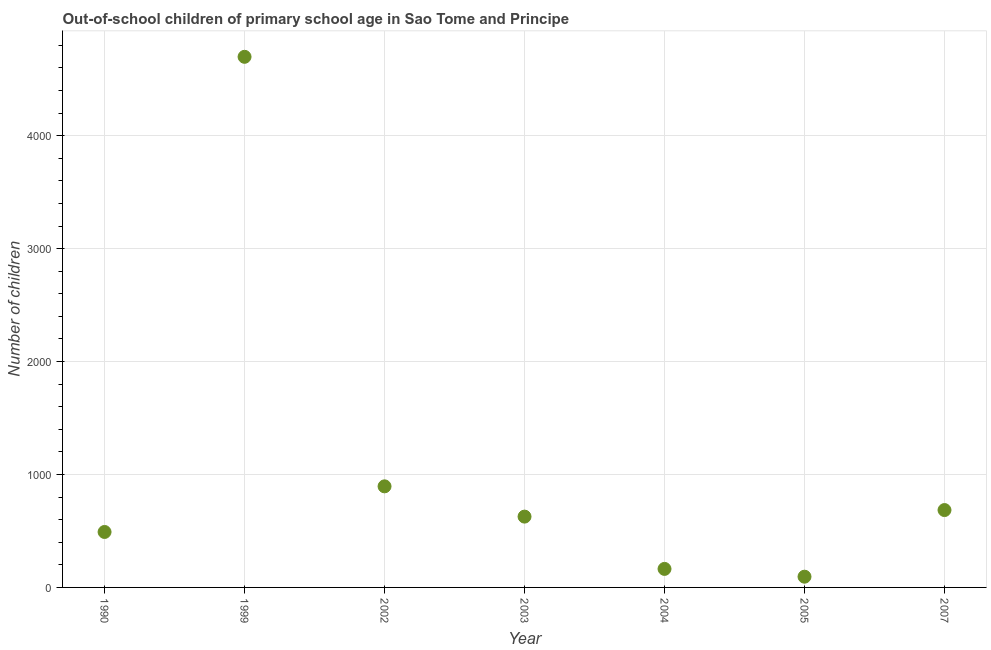What is the number of out-of-school children in 2007?
Your answer should be very brief. 685. Across all years, what is the maximum number of out-of-school children?
Offer a terse response. 4698. Across all years, what is the minimum number of out-of-school children?
Your answer should be compact. 95. What is the sum of the number of out-of-school children?
Offer a very short reply. 7655. What is the difference between the number of out-of-school children in 2005 and 2007?
Your answer should be compact. -590. What is the average number of out-of-school children per year?
Give a very brief answer. 1093.57. What is the median number of out-of-school children?
Your answer should be compact. 627. What is the ratio of the number of out-of-school children in 2004 to that in 2005?
Give a very brief answer. 1.73. What is the difference between the highest and the second highest number of out-of-school children?
Make the answer very short. 3803. Is the sum of the number of out-of-school children in 1999 and 2005 greater than the maximum number of out-of-school children across all years?
Offer a terse response. Yes. What is the difference between the highest and the lowest number of out-of-school children?
Keep it short and to the point. 4603. Does the number of out-of-school children monotonically increase over the years?
Your response must be concise. No. How many dotlines are there?
Give a very brief answer. 1. Are the values on the major ticks of Y-axis written in scientific E-notation?
Provide a succinct answer. No. Does the graph contain any zero values?
Your answer should be very brief. No. What is the title of the graph?
Offer a very short reply. Out-of-school children of primary school age in Sao Tome and Principe. What is the label or title of the Y-axis?
Make the answer very short. Number of children. What is the Number of children in 1990?
Offer a very short reply. 491. What is the Number of children in 1999?
Offer a terse response. 4698. What is the Number of children in 2002?
Provide a short and direct response. 895. What is the Number of children in 2003?
Offer a terse response. 627. What is the Number of children in 2004?
Ensure brevity in your answer.  164. What is the Number of children in 2007?
Your answer should be compact. 685. What is the difference between the Number of children in 1990 and 1999?
Give a very brief answer. -4207. What is the difference between the Number of children in 1990 and 2002?
Provide a short and direct response. -404. What is the difference between the Number of children in 1990 and 2003?
Offer a very short reply. -136. What is the difference between the Number of children in 1990 and 2004?
Your answer should be very brief. 327. What is the difference between the Number of children in 1990 and 2005?
Keep it short and to the point. 396. What is the difference between the Number of children in 1990 and 2007?
Keep it short and to the point. -194. What is the difference between the Number of children in 1999 and 2002?
Your answer should be very brief. 3803. What is the difference between the Number of children in 1999 and 2003?
Make the answer very short. 4071. What is the difference between the Number of children in 1999 and 2004?
Keep it short and to the point. 4534. What is the difference between the Number of children in 1999 and 2005?
Make the answer very short. 4603. What is the difference between the Number of children in 1999 and 2007?
Your response must be concise. 4013. What is the difference between the Number of children in 2002 and 2003?
Provide a succinct answer. 268. What is the difference between the Number of children in 2002 and 2004?
Offer a terse response. 731. What is the difference between the Number of children in 2002 and 2005?
Your response must be concise. 800. What is the difference between the Number of children in 2002 and 2007?
Provide a short and direct response. 210. What is the difference between the Number of children in 2003 and 2004?
Offer a very short reply. 463. What is the difference between the Number of children in 2003 and 2005?
Keep it short and to the point. 532. What is the difference between the Number of children in 2003 and 2007?
Your answer should be compact. -58. What is the difference between the Number of children in 2004 and 2007?
Offer a very short reply. -521. What is the difference between the Number of children in 2005 and 2007?
Make the answer very short. -590. What is the ratio of the Number of children in 1990 to that in 1999?
Keep it short and to the point. 0.1. What is the ratio of the Number of children in 1990 to that in 2002?
Provide a succinct answer. 0.55. What is the ratio of the Number of children in 1990 to that in 2003?
Make the answer very short. 0.78. What is the ratio of the Number of children in 1990 to that in 2004?
Your response must be concise. 2.99. What is the ratio of the Number of children in 1990 to that in 2005?
Keep it short and to the point. 5.17. What is the ratio of the Number of children in 1990 to that in 2007?
Provide a short and direct response. 0.72. What is the ratio of the Number of children in 1999 to that in 2002?
Ensure brevity in your answer.  5.25. What is the ratio of the Number of children in 1999 to that in 2003?
Make the answer very short. 7.49. What is the ratio of the Number of children in 1999 to that in 2004?
Ensure brevity in your answer.  28.65. What is the ratio of the Number of children in 1999 to that in 2005?
Provide a succinct answer. 49.45. What is the ratio of the Number of children in 1999 to that in 2007?
Ensure brevity in your answer.  6.86. What is the ratio of the Number of children in 2002 to that in 2003?
Provide a short and direct response. 1.43. What is the ratio of the Number of children in 2002 to that in 2004?
Provide a succinct answer. 5.46. What is the ratio of the Number of children in 2002 to that in 2005?
Your response must be concise. 9.42. What is the ratio of the Number of children in 2002 to that in 2007?
Offer a terse response. 1.31. What is the ratio of the Number of children in 2003 to that in 2004?
Keep it short and to the point. 3.82. What is the ratio of the Number of children in 2003 to that in 2005?
Make the answer very short. 6.6. What is the ratio of the Number of children in 2003 to that in 2007?
Ensure brevity in your answer.  0.92. What is the ratio of the Number of children in 2004 to that in 2005?
Your answer should be compact. 1.73. What is the ratio of the Number of children in 2004 to that in 2007?
Your answer should be compact. 0.24. What is the ratio of the Number of children in 2005 to that in 2007?
Your answer should be very brief. 0.14. 